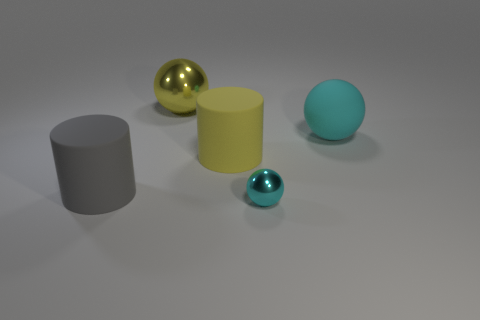Subtract all yellow balls. How many balls are left? 2 Subtract all yellow balls. How many balls are left? 2 Subtract 1 cylinders. How many cylinders are left? 1 Subtract all purple cubes. How many yellow balls are left? 1 Add 1 small red metal things. How many objects exist? 6 Subtract all cylinders. How many objects are left? 3 Subtract all green spheres. Subtract all brown blocks. How many spheres are left? 3 Add 5 small objects. How many small objects exist? 6 Subtract 0 blue cylinders. How many objects are left? 5 Subtract all big gray rubber things. Subtract all cyan metal objects. How many objects are left? 3 